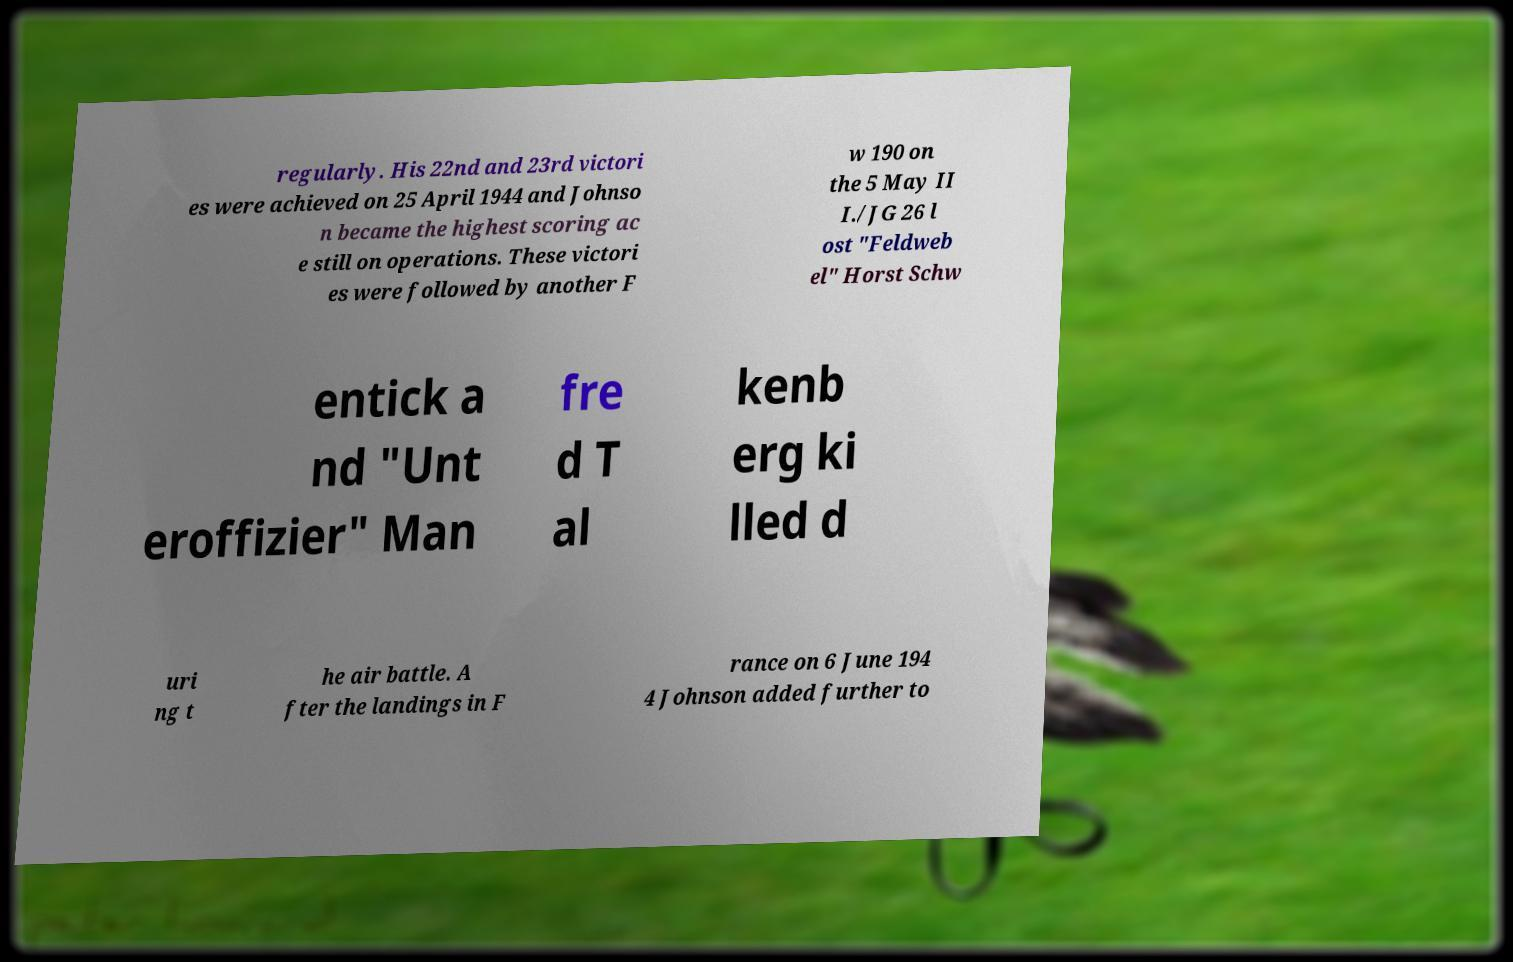Please identify and transcribe the text found in this image. regularly. His 22nd and 23rd victori es were achieved on 25 April 1944 and Johnso n became the highest scoring ac e still on operations. These victori es were followed by another F w 190 on the 5 May II I./JG 26 l ost "Feldweb el" Horst Schw entick a nd "Unt eroffizier" Man fre d T al kenb erg ki lled d uri ng t he air battle. A fter the landings in F rance on 6 June 194 4 Johnson added further to 